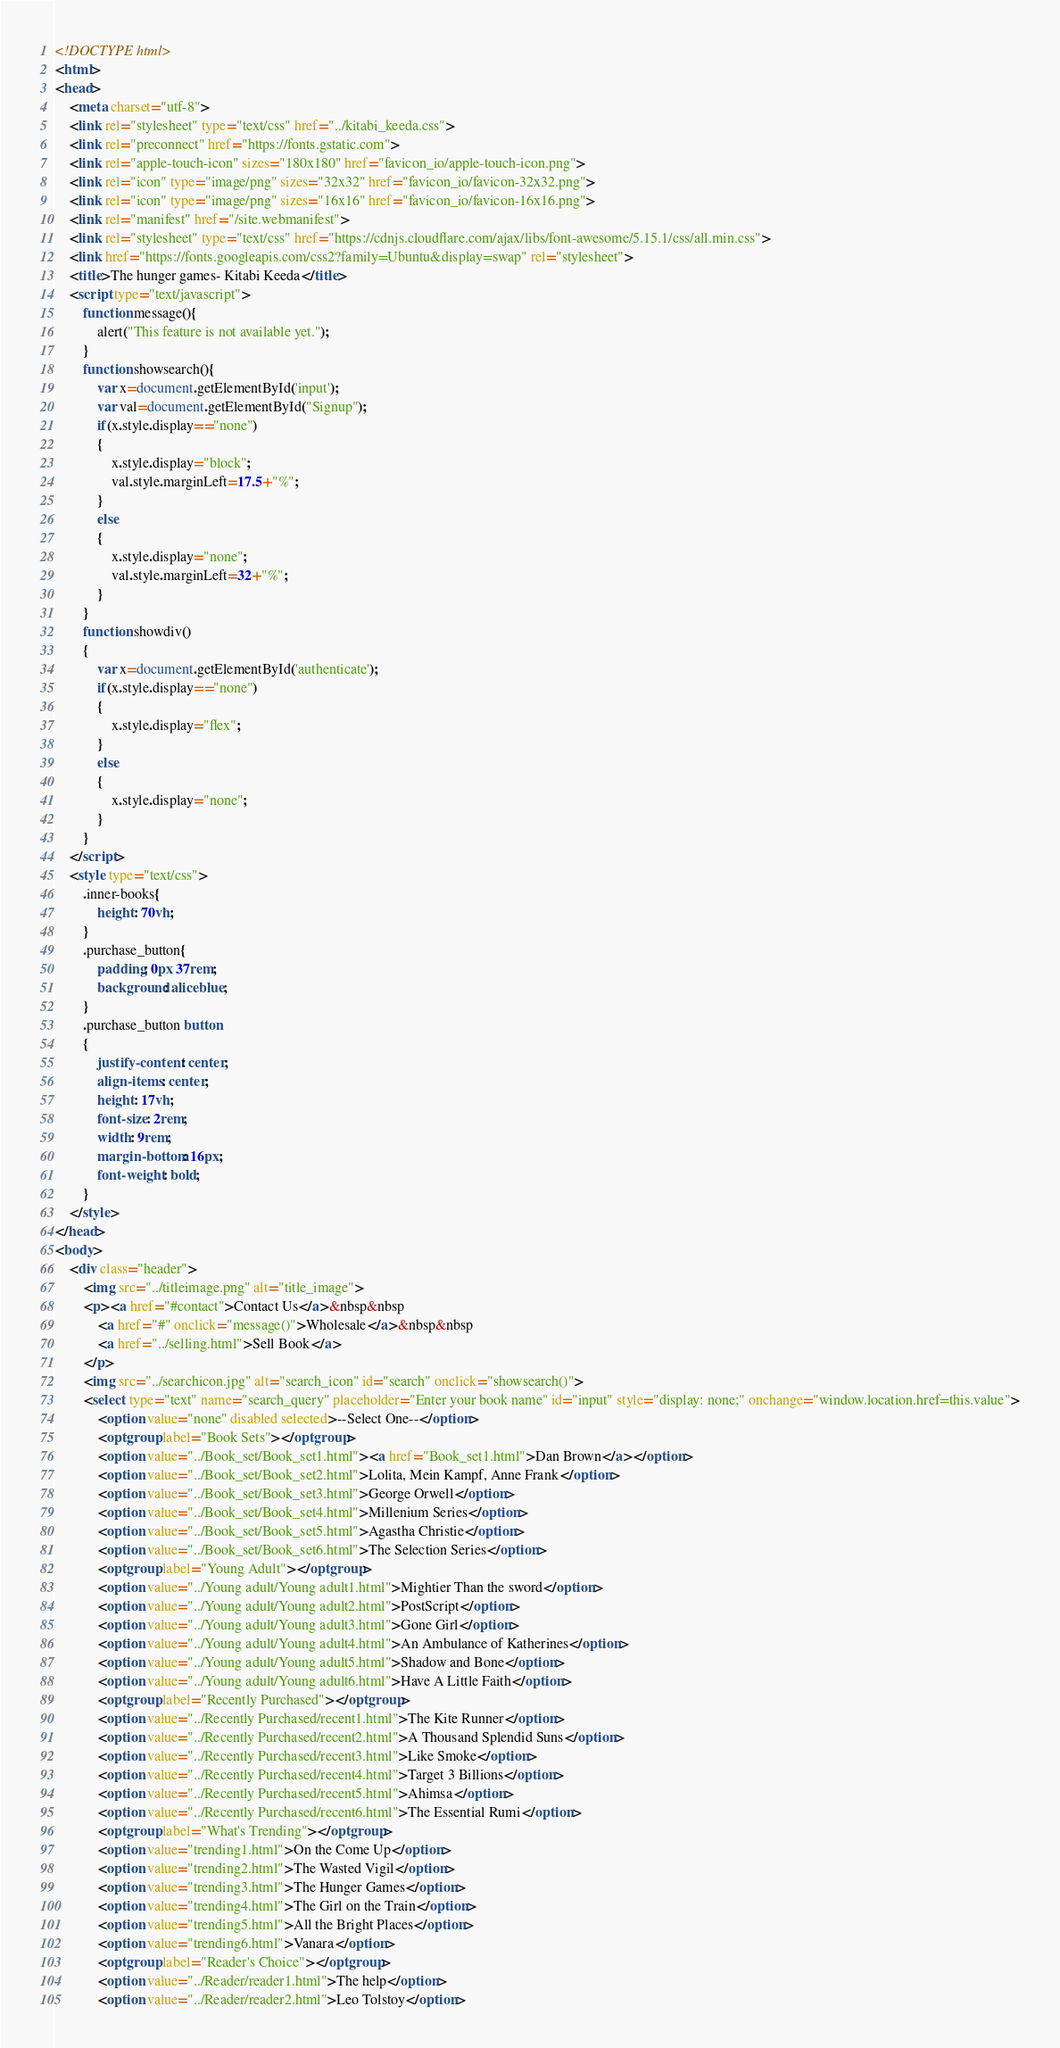<code> <loc_0><loc_0><loc_500><loc_500><_HTML_><!DOCTYPE html>
<html>
<head>
	<meta charset="utf-8">
	<link rel="stylesheet" type="text/css" href="../kitabi_keeda.css">
	<link rel="preconnect" href="https://fonts.gstatic.com">
	<link rel="apple-touch-icon" sizes="180x180" href="favicon_io/apple-touch-icon.png">
	<link rel="icon" type="image/png" sizes="32x32" href="favicon_io/favicon-32x32.png">
	<link rel="icon" type="image/png" sizes="16x16" href="favicon_io/favicon-16x16.png">
	<link rel="manifest" href="/site.webmanifest">
	<link rel="stylesheet" type="text/css" href="https://cdnjs.cloudflare.com/ajax/libs/font-awesome/5.15.1/css/all.min.css">
	<link href="https://fonts.googleapis.com/css2?family=Ubuntu&display=swap" rel="stylesheet">
	<title>The hunger games- Kitabi Keeda</title>
	<script type="text/javascript">
		function message(){
			alert("This feature is not available yet.");
		}
		function showsearch(){
			var x=document.getElementById('input');
			var val=document.getElementById("Signup");
            if(x.style.display=="none")
            {
                x.style.display="block";
                val.style.marginLeft=17.5+"%";
            }
            else
            {
                x.style.display="none";    
                val.style.marginLeft=32+"%";          
            }
		}
		function showdiv()
        {
            var x=document.getElementById('authenticate');
            if(x.style.display=="none")
            {
                x.style.display="flex";
            }
            else
            {
                x.style.display="none";
            }
        }
    </script>
    <style type="text/css">
    	.inner-books{
    		height: 70vh;
    	}
    	.purchase_button{
    		padding: 0px 37rem;
		    background: aliceblue;
    	}
    	.purchase_button button
    	{
    		justify-content: center;
		    align-items: center;
		    height: 17vh;
		    font-size: 2rem;
		    width: 9rem;
		    margin-bottom: 16px;
		    font-weight: bold;
    	}
    </style>
</head>
<body>
	<div class="header">
		<img src="../titleimage.png" alt="title_image">
		<p><a href="#contact">Contact Us</a>&nbsp&nbsp
			<a href="#" onclick="message()">Wholesale</a>&nbsp&nbsp
			<a href="../selling.html">Sell Book</a>
		</p>
		<img src="../searchicon.jpg" alt="search_icon" id="search" onclick="showsearch()">
		<select type="text" name="search_query" placeholder="Enter your book name" id="input" style="display: none;" onchange="window.location.href=this.value">
			<option value="none" disabled selected>--Select One--</option>
			<optgroup label="Book Sets"></optgroup>
			<option value="../Book_set/Book_set1.html"><a href="Book_set1.html">Dan Brown</a></option>
			<option value="../Book_set/Book_set2.html">Lolita, Mein Kampf, Anne Frank</option>
			<option value="../Book_set/Book_set3.html">George Orwell</option>
			<option value="../Book_set/Book_set4.html">Millenium Series</option>
			<option value="../Book_set/Book_set5.html">Agastha Christie</option>
			<option value="../Book_set/Book_set6.html">The Selection Series</option>
			<optgroup label="Young Adult"></optgroup>
			<option value="../Young adult/Young adult1.html">Mightier Than the sword</option>
			<option value="../Young adult/Young adult2.html">PostScript</option>
			<option value="../Young adult/Young adult3.html">Gone Girl</option>
			<option value="../Young adult/Young adult4.html">An Ambulance of Katherines</option>
			<option value="../Young adult/Young adult5.html">Shadow and Bone</option>
			<option value="../Young adult/Young adult6.html">Have A Little Faith</option>
			<optgroup label="Recently Purchased"></optgroup>
			<option value="../Recently Purchased/recent1.html">The Kite Runner</option>
			<option value="../Recently Purchased/recent2.html">A Thousand Splendid Suns</option>
			<option value="../Recently Purchased/recent3.html">Like Smoke</option>
			<option value="../Recently Purchased/recent4.html">Target 3 Billions</option>
			<option value="../Recently Purchased/recent5.html">Ahimsa</option>
			<option value="../Recently Purchased/recent6.html">The Essential Rumi</option>
			<optgroup label="What's Trending"></optgroup>
			<option value="trending1.html">On the Come Up</option>
			<option value="trending2.html">The Wasted Vigil</option>
			<option value="trending3.html">The Hunger Games</option>
			<option value="trending4.html">The Girl on the Train</option>
			<option value="trending5.html">All the Bright Places</option>
			<option value="trending6.html">Vanara</option>
			<optgroup label="Reader's Choice"></optgroup>
			<option value="../Reader/reader1.html">The help</option>
			<option value="../Reader/reader2.html">Leo Tolstoy</option></code> 